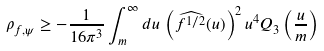<formula> <loc_0><loc_0><loc_500><loc_500>\rho _ { f , \psi } \geq - \frac { 1 } { 1 6 \pi ^ { 3 } } \int _ { m } ^ { \infty } d u \, \left ( \widehat { f ^ { 1 / 2 } } ( u ) \right ) ^ { 2 } u ^ { 4 } Q _ { 3 } \left ( \frac { u } { m } \right )</formula> 